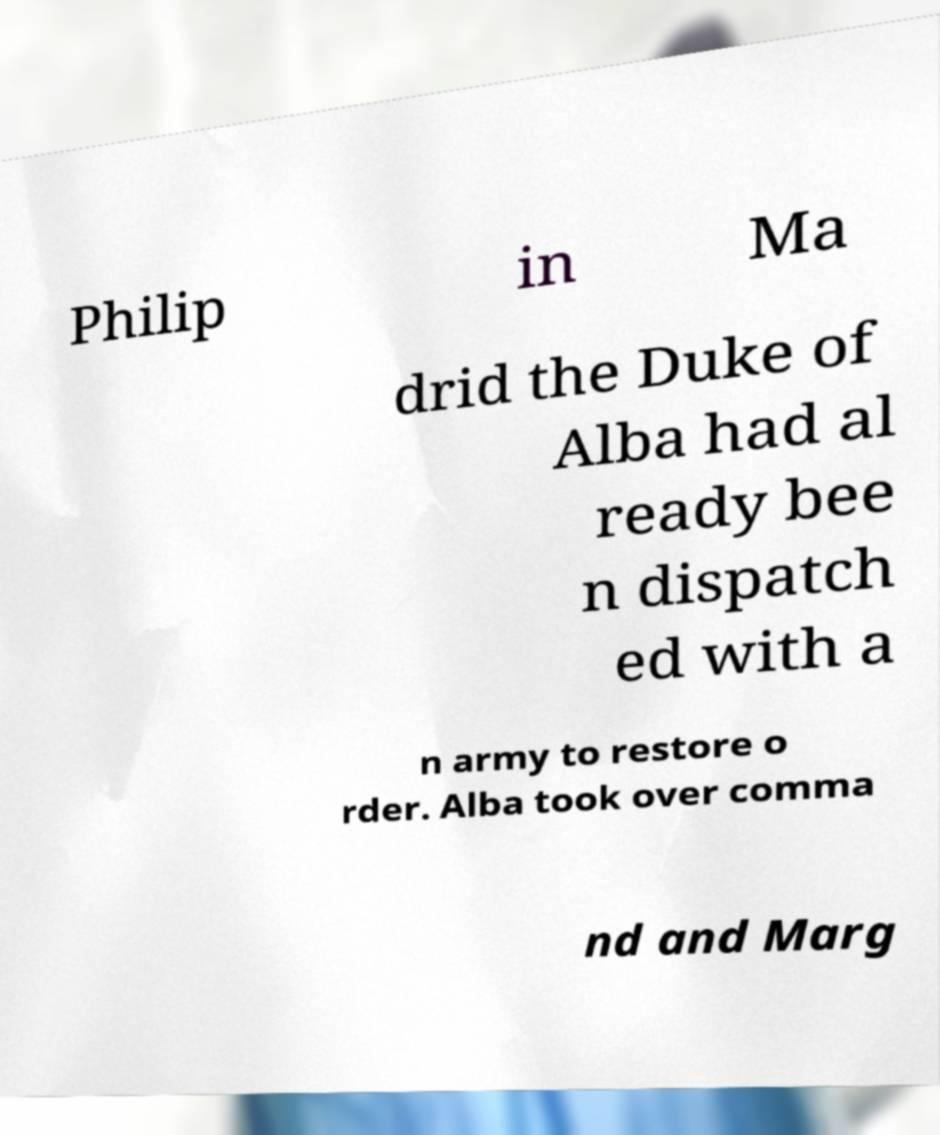Can you read and provide the text displayed in the image?This photo seems to have some interesting text. Can you extract and type it out for me? Philip in Ma drid the Duke of Alba had al ready bee n dispatch ed with a n army to restore o rder. Alba took over comma nd and Marg 